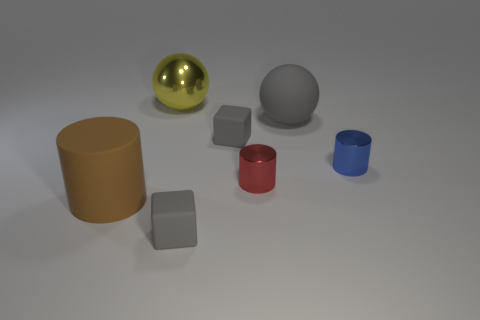Add 1 big cyan spheres. How many objects exist? 8 Subtract all cylinders. How many objects are left? 4 Add 1 rubber cubes. How many rubber cubes are left? 3 Add 7 large brown matte cylinders. How many large brown matte cylinders exist? 8 Subtract 0 purple spheres. How many objects are left? 7 Subtract all small cylinders. Subtract all large matte balls. How many objects are left? 4 